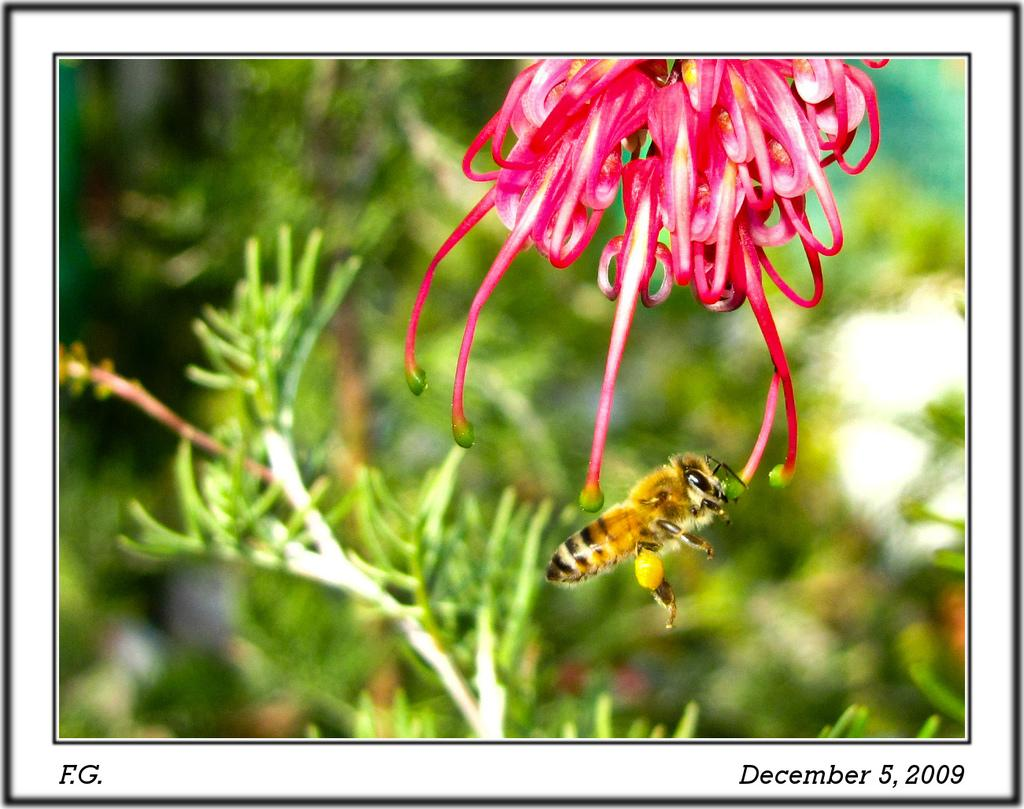What is present in the image? There is a plant in the image. What feature can be observed on the plant? The plant has a flower at the top. What is the color of the flower? The flower is pink in color. Are there any other living organisms in the image? Yes, there is a honey bee in the image. What type of suit is the lettuce wearing in the image? There is no lettuce present in the image, and therefore no suit can be observed. 